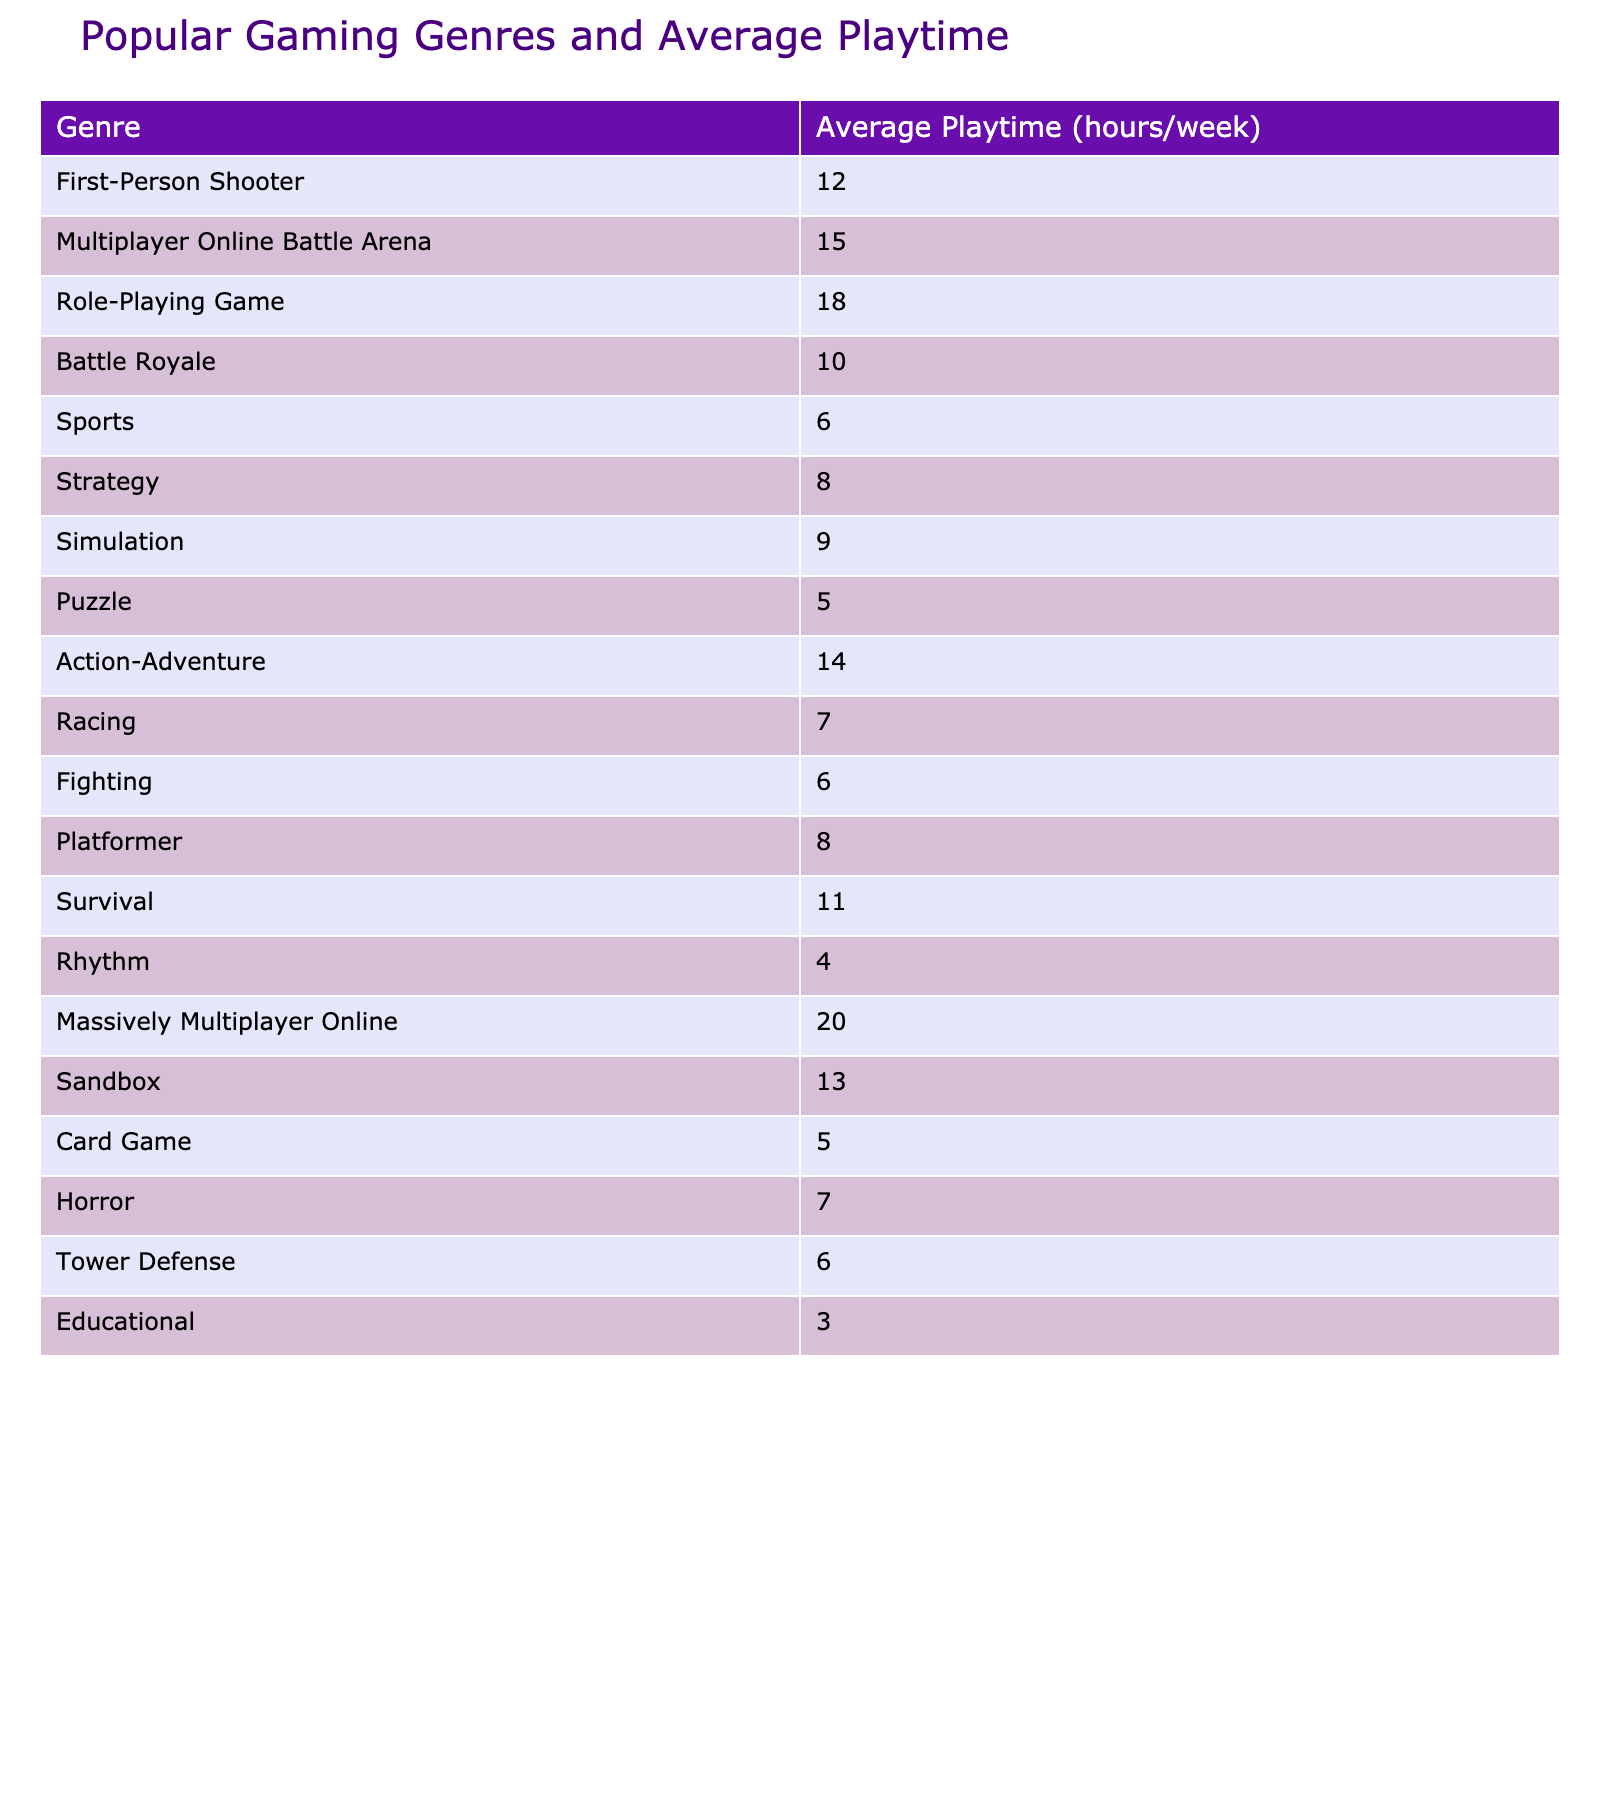What is the average playtime for the Role-Playing Game genre? The table lists the average playtime for the Role-Playing Game genre as 18 hours per week.
Answer: 18 hours Which gaming genre has the highest average playtime? By reviewing the table, the Massively Multiplayer Online genre has the highest average playtime, recorded at 20 hours per week.
Answer: Massively Multiplayer Online What is the total average playtime for the Horror and Action-Adventure genres combined? Adding the average playtimes from the table, Horror has 7 hours, and Action-Adventure has 14 hours. Therefore, the total is 7 + 14 = 21 hours.
Answer: 21 hours Is the average playtime for Sports higher than that for Puzzle? The average playtime for Sports is 6 hours, while for Puzzle, it is 5 hours. Since 6 is greater than 5, the statement is true.
Answer: Yes What is the difference in average playtime between the Strategy and Battle Royale genres? The average playtime for Strategy is 8 hours and for Battle Royale is 10 hours. The difference is calculated as 10 - 8 = 2 hours.
Answer: 2 hours Identify the gaming genres that have an average playtime less than 8 hours. By examining the table, the genres with less than 8 hours are Sports (6), Puzzle (5), Fighting (6), and Educational (3). These genres all fall below the 8-hour mark.
Answer: Sports, Puzzle, Fighting, Educational What is the average playtime of the genres that fall in the Action category (Action-Adventure, Fighting, and Racing)? The average playtime for Action-Adventure is 14 hours, Fighting is 6 hours, and Racing is 7 hours. First, sum these values: 14 + 6 + 7 = 27 hours. Then divide by 3 (the number of genres): 27 / 3 = 9 hours.
Answer: 9 hours Which genre has the lowest average playtime, and what is that time? Upon checking the table, Educational genre has the lowest average playtime, which is 3 hours.
Answer: Educational, 3 hours How many genres have an average playtime greater than 10 hours? In the table, the genres that have greater than 10 hours of playtime are: Massively Multiplayer Online (20), Role-Playing Game (18), Multiplayer Online Battle Arena (15), Action-Adventure (14), and Sandbox (13). This gives a total of 5 genres.
Answer: 5 genres What is the combined average playtime for the two genres with the least playtime? The two genres with the least playtime are Educational with 3 hours and Rhythm with 4 hours. Their combined average is calculated by adding the two values (3 + 4 = 7 hours) and then dividing by 2 (the number of genres): 7 / 2 = 3.5 hours.
Answer: 3.5 hours 